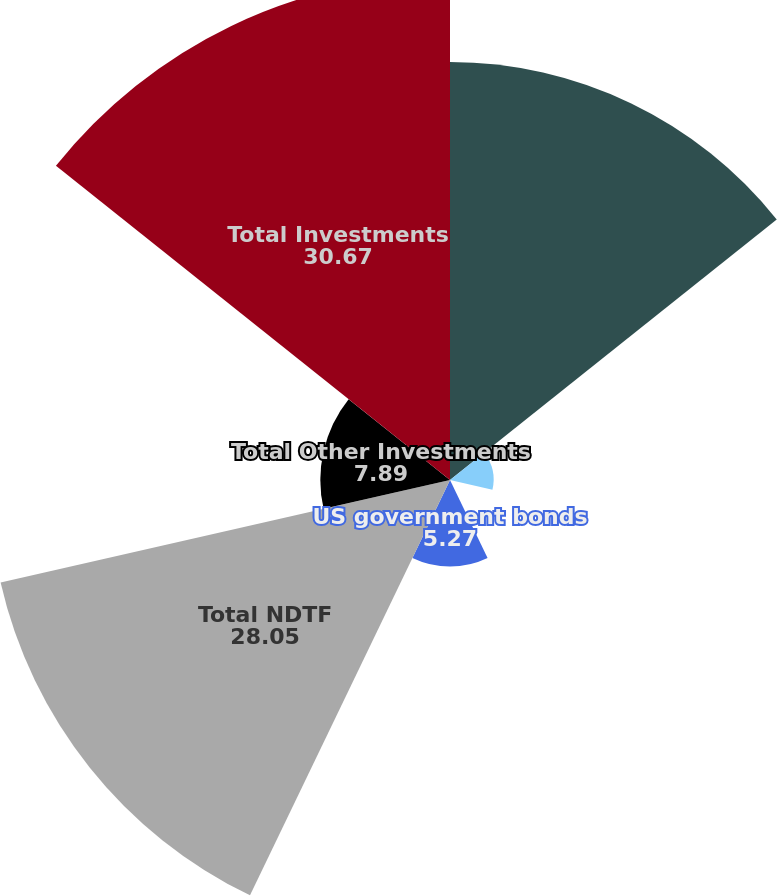Convert chart to OTSL. <chart><loc_0><loc_0><loc_500><loc_500><pie_chart><fcel>Equity securities<fcel>Corporate debt securities<fcel>Municipal bonds<fcel>US government bonds<fcel>Total NDTF<fcel>Total Other Investments<fcel>Total Investments<nl><fcel>25.43%<fcel>2.65%<fcel>0.04%<fcel>5.27%<fcel>28.05%<fcel>7.89%<fcel>30.67%<nl></chart> 